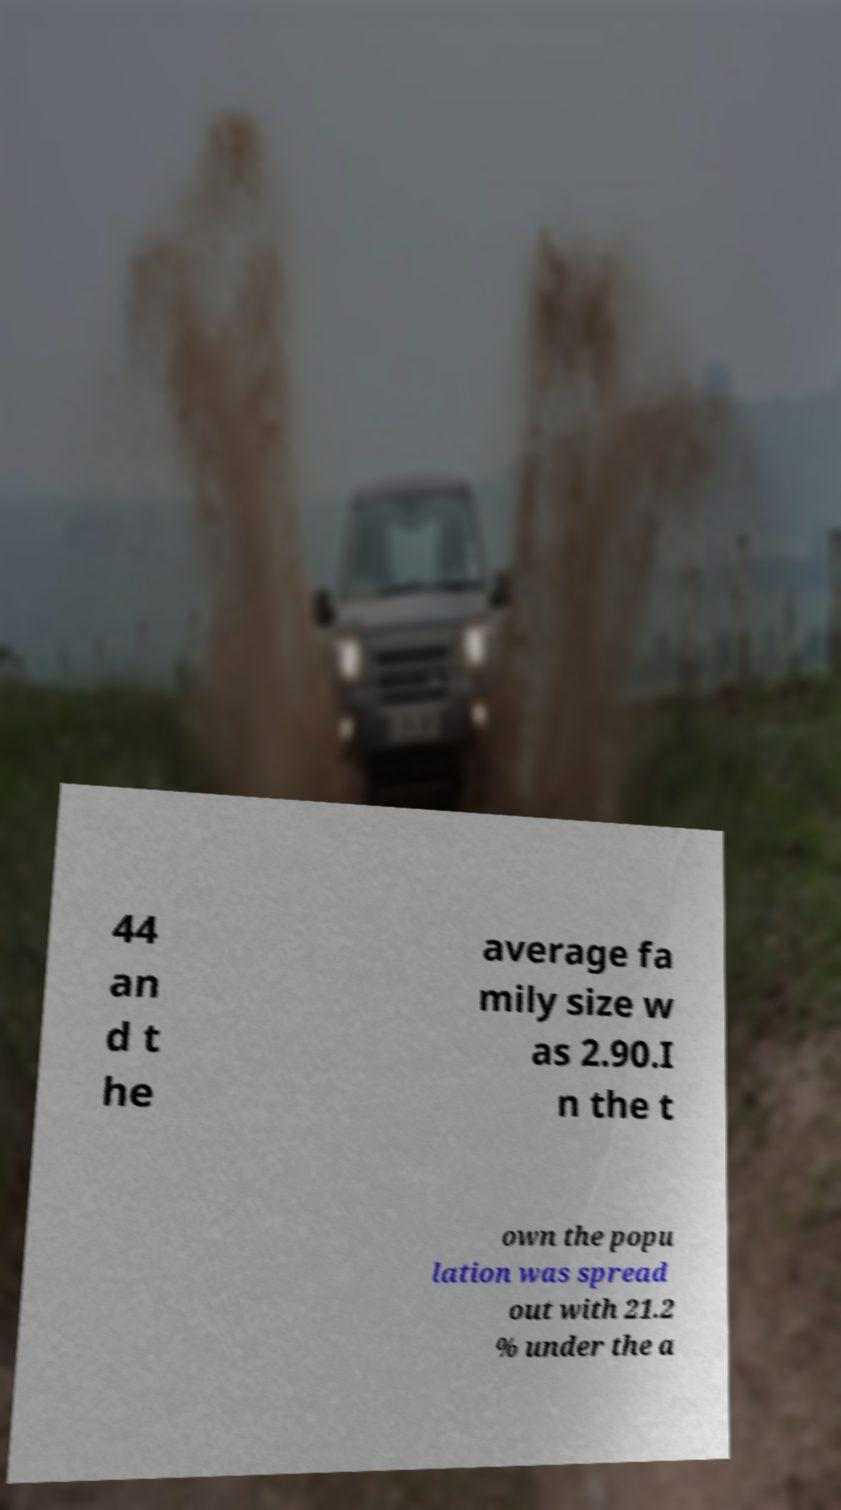For documentation purposes, I need the text within this image transcribed. Could you provide that? 44 an d t he average fa mily size w as 2.90.I n the t own the popu lation was spread out with 21.2 % under the a 